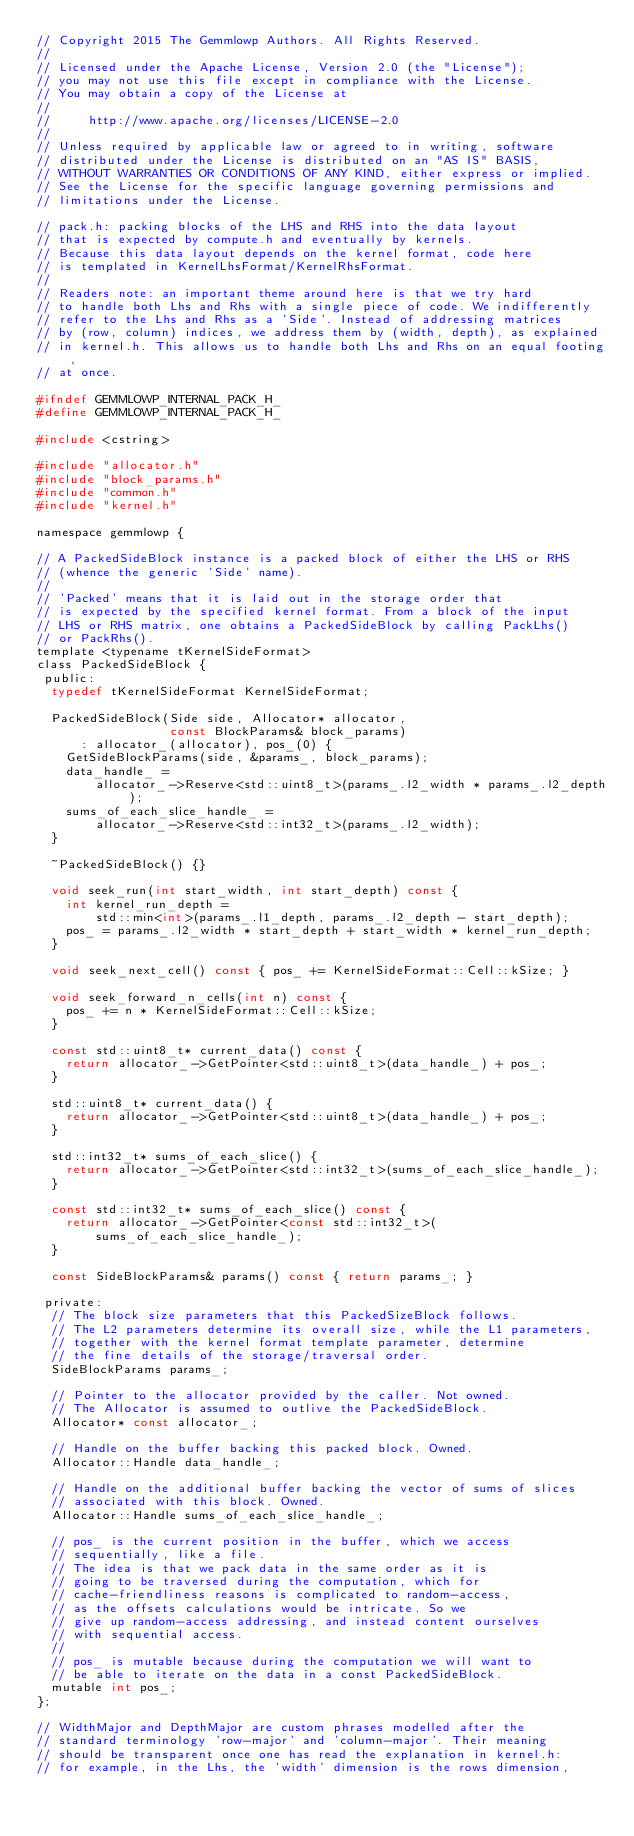Convert code to text. <code><loc_0><loc_0><loc_500><loc_500><_C_>// Copyright 2015 The Gemmlowp Authors. All Rights Reserved.
//
// Licensed under the Apache License, Version 2.0 (the "License");
// you may not use this file except in compliance with the License.
// You may obtain a copy of the License at
//
//     http://www.apache.org/licenses/LICENSE-2.0
//
// Unless required by applicable law or agreed to in writing, software
// distributed under the License is distributed on an "AS IS" BASIS,
// WITHOUT WARRANTIES OR CONDITIONS OF ANY KIND, either express or implied.
// See the License for the specific language governing permissions and
// limitations under the License.

// pack.h: packing blocks of the LHS and RHS into the data layout
// that is expected by compute.h and eventually by kernels.
// Because this data layout depends on the kernel format, code here
// is templated in KernelLhsFormat/KernelRhsFormat.
//
// Readers note: an important theme around here is that we try hard
// to handle both Lhs and Rhs with a single piece of code. We indifferently
// refer to the Lhs and Rhs as a 'Side'. Instead of addressing matrices
// by (row, column) indices, we address them by (width, depth), as explained
// in kernel.h. This allows us to handle both Lhs and Rhs on an equal footing,
// at once.

#ifndef GEMMLOWP_INTERNAL_PACK_H_
#define GEMMLOWP_INTERNAL_PACK_H_

#include <cstring>

#include "allocator.h"
#include "block_params.h"
#include "common.h"
#include "kernel.h"

namespace gemmlowp {

// A PackedSideBlock instance is a packed block of either the LHS or RHS
// (whence the generic 'Side' name).
//
// 'Packed' means that it is laid out in the storage order that
// is expected by the specified kernel format. From a block of the input
// LHS or RHS matrix, one obtains a PackedSideBlock by calling PackLhs()
// or PackRhs().
template <typename tKernelSideFormat>
class PackedSideBlock {
 public:
  typedef tKernelSideFormat KernelSideFormat;

  PackedSideBlock(Side side, Allocator* allocator,
                  const BlockParams& block_params)
      : allocator_(allocator), pos_(0) {
    GetSideBlockParams(side, &params_, block_params);
    data_handle_ =
        allocator_->Reserve<std::uint8_t>(params_.l2_width * params_.l2_depth);
    sums_of_each_slice_handle_ =
        allocator_->Reserve<std::int32_t>(params_.l2_width);
  }

  ~PackedSideBlock() {}

  void seek_run(int start_width, int start_depth) const {
    int kernel_run_depth =
        std::min<int>(params_.l1_depth, params_.l2_depth - start_depth);
    pos_ = params_.l2_width * start_depth + start_width * kernel_run_depth;
  }

  void seek_next_cell() const { pos_ += KernelSideFormat::Cell::kSize; }

  void seek_forward_n_cells(int n) const {
    pos_ += n * KernelSideFormat::Cell::kSize;
  }

  const std::uint8_t* current_data() const {
    return allocator_->GetPointer<std::uint8_t>(data_handle_) + pos_;
  }

  std::uint8_t* current_data() {
    return allocator_->GetPointer<std::uint8_t>(data_handle_) + pos_;
  }

  std::int32_t* sums_of_each_slice() {
    return allocator_->GetPointer<std::int32_t>(sums_of_each_slice_handle_);
  }

  const std::int32_t* sums_of_each_slice() const {
    return allocator_->GetPointer<const std::int32_t>(
        sums_of_each_slice_handle_);
  }

  const SideBlockParams& params() const { return params_; }

 private:
  // The block size parameters that this PackedSizeBlock follows.
  // The L2 parameters determine its overall size, while the L1 parameters,
  // together with the kernel format template parameter, determine
  // the fine details of the storage/traversal order.
  SideBlockParams params_;

  // Pointer to the allocator provided by the caller. Not owned.
  // The Allocator is assumed to outlive the PackedSideBlock.
  Allocator* const allocator_;

  // Handle on the buffer backing this packed block. Owned.
  Allocator::Handle data_handle_;

  // Handle on the additional buffer backing the vector of sums of slices
  // associated with this block. Owned.
  Allocator::Handle sums_of_each_slice_handle_;

  // pos_ is the current position in the buffer, which we access
  // sequentially, like a file.
  // The idea is that we pack data in the same order as it is
  // going to be traversed during the computation, which for
  // cache-friendliness reasons is complicated to random-access,
  // as the offsets calculations would be intricate. So we
  // give up random-access addressing, and instead content ourselves
  // with sequential access.
  //
  // pos_ is mutable because during the computation we will want to
  // be able to iterate on the data in a const PackedSideBlock.
  mutable int pos_;
};

// WidthMajor and DepthMajor are custom phrases modelled after the
// standard terminology 'row-major' and 'column-major'. Their meaning
// should be transparent once one has read the explanation in kernel.h:
// for example, in the Lhs, the 'width' dimension is the rows dimension,</code> 